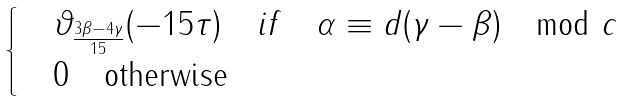<formula> <loc_0><loc_0><loc_500><loc_500>\begin{cases} \quad \vartheta _ { \frac { 3 \beta - 4 \gamma } { 1 5 } } ( - 1 5 \tau ) \quad i f \quad \alpha \equiv d ( \gamma - \beta ) \mod c \\ \quad 0 \quad \text {otherwise} \end{cases}</formula> 